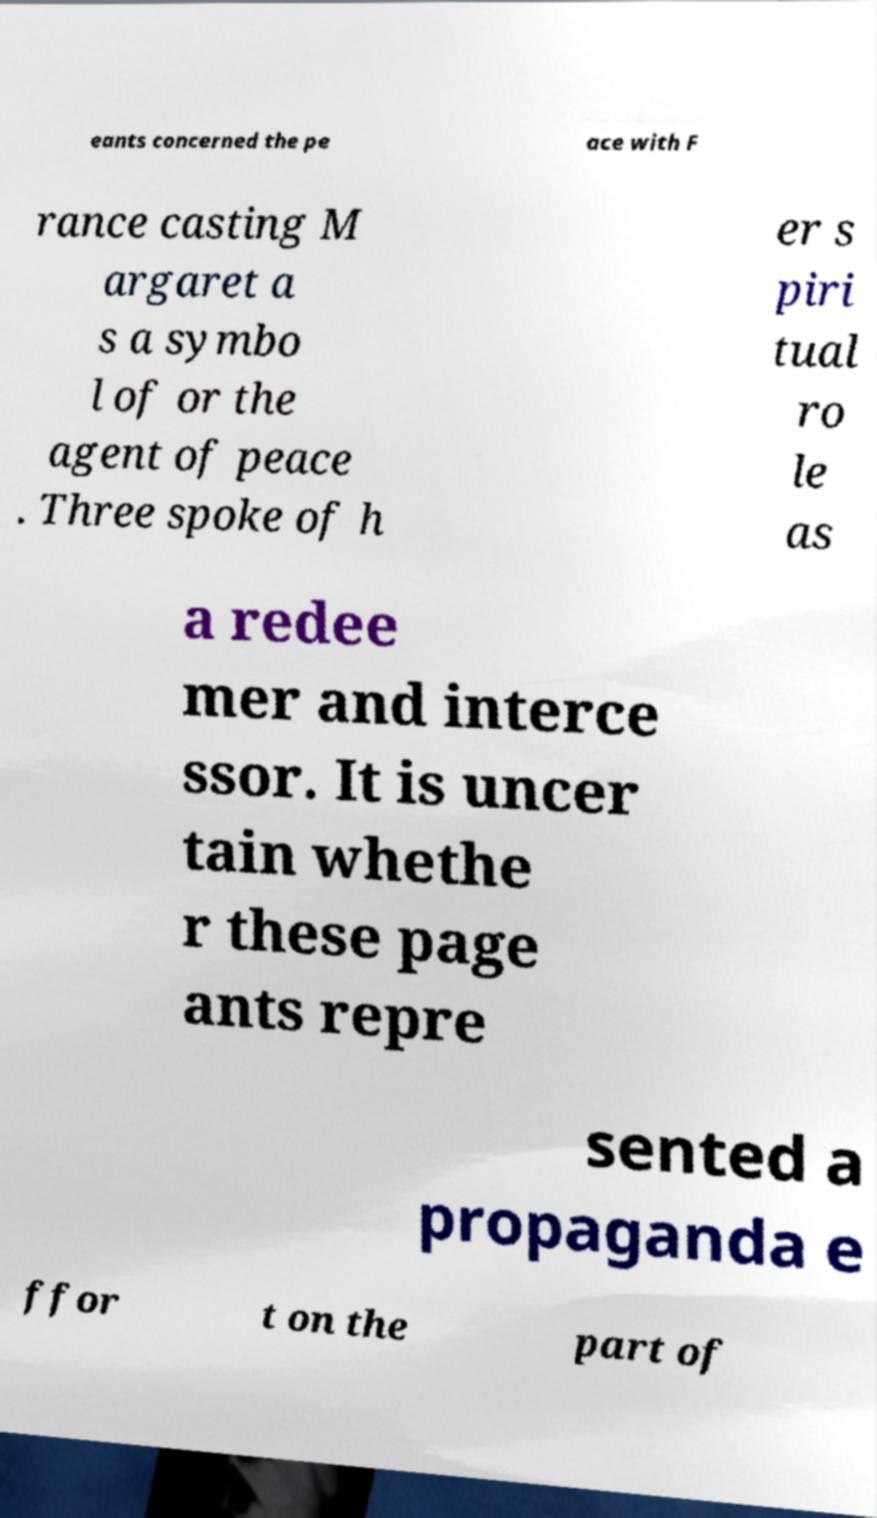Please read and relay the text visible in this image. What does it say? eants concerned the pe ace with F rance casting M argaret a s a symbo l of or the agent of peace . Three spoke of h er s piri tual ro le as a redee mer and interce ssor. It is uncer tain whethe r these page ants repre sented a propaganda e ffor t on the part of 